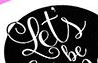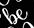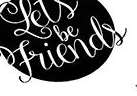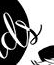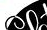Read the text from these images in sequence, separated by a semicolon. Let's; be; Friends; ds; ## 